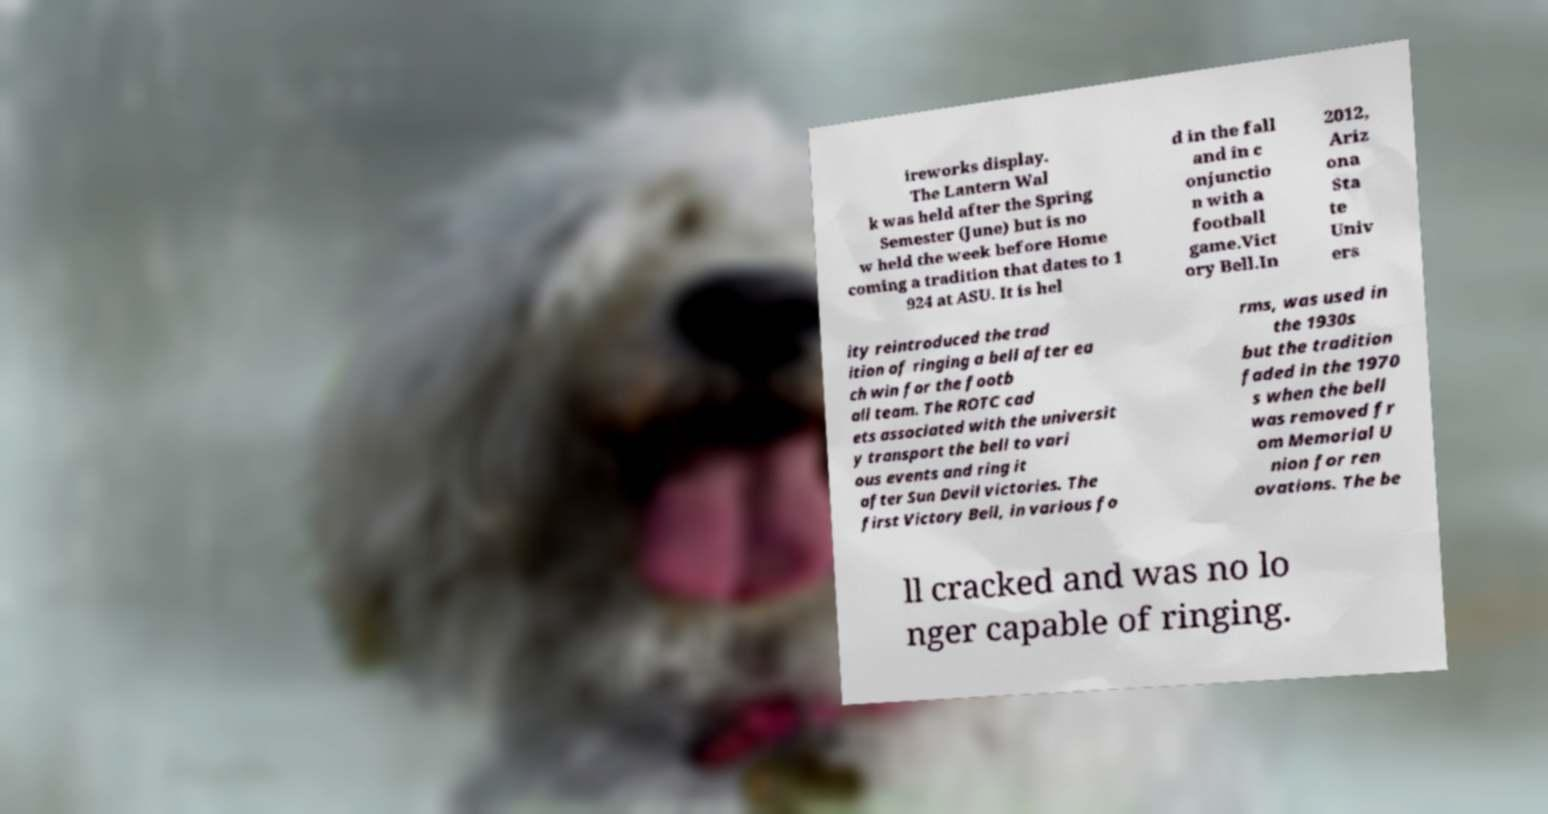There's text embedded in this image that I need extracted. Can you transcribe it verbatim? ireworks display. The Lantern Wal k was held after the Spring Semester (June) but is no w held the week before Home coming a tradition that dates to 1 924 at ASU. It is hel d in the fall and in c onjunctio n with a football game.Vict ory Bell.In 2012, Ariz ona Sta te Univ ers ity reintroduced the trad ition of ringing a bell after ea ch win for the footb all team. The ROTC cad ets associated with the universit y transport the bell to vari ous events and ring it after Sun Devil victories. The first Victory Bell, in various fo rms, was used in the 1930s but the tradition faded in the 1970 s when the bell was removed fr om Memorial U nion for ren ovations. The be ll cracked and was no lo nger capable of ringing. 